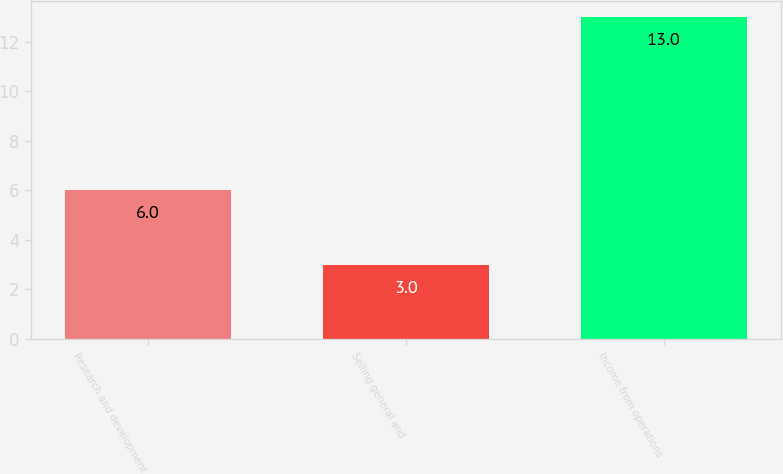Convert chart to OTSL. <chart><loc_0><loc_0><loc_500><loc_500><bar_chart><fcel>Research and development<fcel>Selling general and<fcel>Income from operations<nl><fcel>6<fcel>3<fcel>13<nl></chart> 